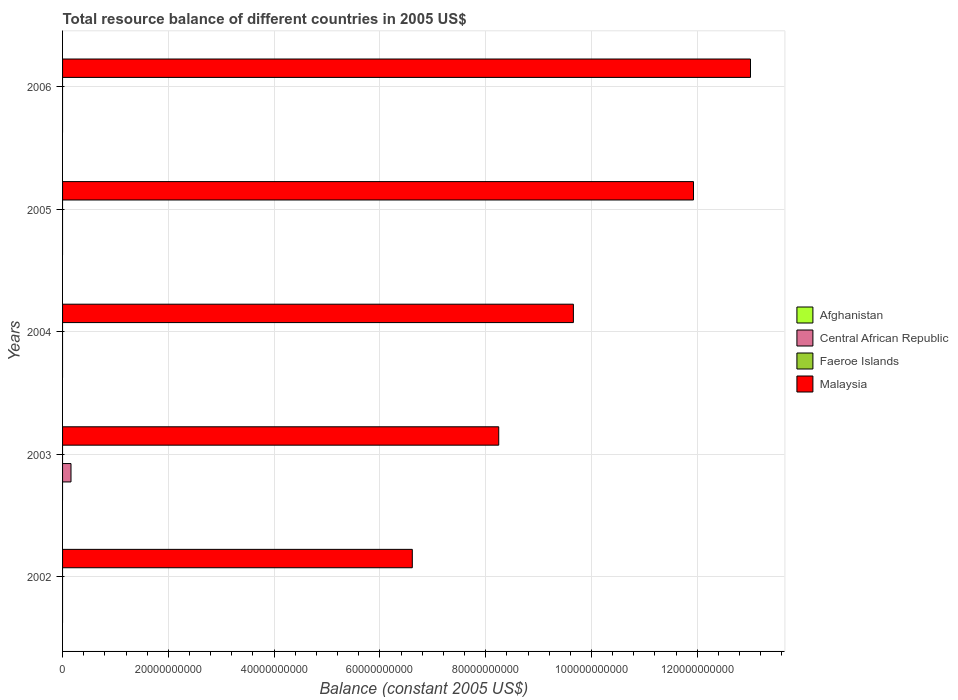Are the number of bars per tick equal to the number of legend labels?
Ensure brevity in your answer.  No. How many bars are there on the 5th tick from the bottom?
Provide a succinct answer. 1. What is the label of the 5th group of bars from the top?
Make the answer very short. 2002. What is the total resource balance in Malaysia in 2005?
Your answer should be compact. 1.19e+11. Across all years, what is the maximum total resource balance in Central African Republic?
Make the answer very short. 1.60e+09. Across all years, what is the minimum total resource balance in Central African Republic?
Give a very brief answer. 0. What is the total total resource balance in Faeroe Islands in the graph?
Offer a terse response. 0. What is the difference between the total resource balance in Malaysia in 2003 and that in 2004?
Your response must be concise. -1.41e+1. What is the difference between the total resource balance in Malaysia in 2006 and the total resource balance in Faeroe Islands in 2005?
Give a very brief answer. 1.30e+11. What is the average total resource balance in Central African Republic per year?
Offer a terse response. 3.19e+08. In how many years, is the total resource balance in Afghanistan greater than 64000000000 US$?
Offer a terse response. 0. What is the difference between the highest and the lowest total resource balance in Malaysia?
Your answer should be very brief. 6.39e+1. In how many years, is the total resource balance in Afghanistan greater than the average total resource balance in Afghanistan taken over all years?
Your answer should be very brief. 0. Is the sum of the total resource balance in Malaysia in 2002 and 2004 greater than the maximum total resource balance in Afghanistan across all years?
Keep it short and to the point. Yes. Is it the case that in every year, the sum of the total resource balance in Central African Republic and total resource balance in Faeroe Islands is greater than the sum of total resource balance in Malaysia and total resource balance in Afghanistan?
Provide a short and direct response. No. Is it the case that in every year, the sum of the total resource balance in Afghanistan and total resource balance in Faeroe Islands is greater than the total resource balance in Central African Republic?
Offer a terse response. No. What is the difference between two consecutive major ticks on the X-axis?
Keep it short and to the point. 2.00e+1. Does the graph contain grids?
Offer a terse response. Yes. Where does the legend appear in the graph?
Ensure brevity in your answer.  Center right. How are the legend labels stacked?
Provide a short and direct response. Vertical. What is the title of the graph?
Offer a terse response. Total resource balance of different countries in 2005 US$. Does "Other small states" appear as one of the legend labels in the graph?
Make the answer very short. No. What is the label or title of the X-axis?
Offer a terse response. Balance (constant 2005 US$). What is the label or title of the Y-axis?
Ensure brevity in your answer.  Years. What is the Balance (constant 2005 US$) of Malaysia in 2002?
Give a very brief answer. 6.61e+1. What is the Balance (constant 2005 US$) of Central African Republic in 2003?
Make the answer very short. 1.60e+09. What is the Balance (constant 2005 US$) of Malaysia in 2003?
Your answer should be compact. 8.25e+1. What is the Balance (constant 2005 US$) of Central African Republic in 2004?
Provide a short and direct response. 0. What is the Balance (constant 2005 US$) in Malaysia in 2004?
Offer a terse response. 9.66e+1. What is the Balance (constant 2005 US$) of Faeroe Islands in 2005?
Ensure brevity in your answer.  0. What is the Balance (constant 2005 US$) of Malaysia in 2005?
Offer a very short reply. 1.19e+11. What is the Balance (constant 2005 US$) in Central African Republic in 2006?
Provide a succinct answer. 0. What is the Balance (constant 2005 US$) in Faeroe Islands in 2006?
Your answer should be compact. 0. What is the Balance (constant 2005 US$) in Malaysia in 2006?
Provide a succinct answer. 1.30e+11. Across all years, what is the maximum Balance (constant 2005 US$) of Central African Republic?
Ensure brevity in your answer.  1.60e+09. Across all years, what is the maximum Balance (constant 2005 US$) of Malaysia?
Make the answer very short. 1.30e+11. Across all years, what is the minimum Balance (constant 2005 US$) of Central African Republic?
Provide a short and direct response. 0. Across all years, what is the minimum Balance (constant 2005 US$) of Malaysia?
Give a very brief answer. 6.61e+1. What is the total Balance (constant 2005 US$) of Central African Republic in the graph?
Your answer should be compact. 1.60e+09. What is the total Balance (constant 2005 US$) in Malaysia in the graph?
Offer a very short reply. 4.94e+11. What is the difference between the Balance (constant 2005 US$) of Malaysia in 2002 and that in 2003?
Offer a very short reply. -1.63e+1. What is the difference between the Balance (constant 2005 US$) of Malaysia in 2002 and that in 2004?
Your answer should be very brief. -3.05e+1. What is the difference between the Balance (constant 2005 US$) in Malaysia in 2002 and that in 2005?
Your answer should be very brief. -5.32e+1. What is the difference between the Balance (constant 2005 US$) of Malaysia in 2002 and that in 2006?
Give a very brief answer. -6.39e+1. What is the difference between the Balance (constant 2005 US$) in Malaysia in 2003 and that in 2004?
Ensure brevity in your answer.  -1.41e+1. What is the difference between the Balance (constant 2005 US$) in Malaysia in 2003 and that in 2005?
Provide a short and direct response. -3.68e+1. What is the difference between the Balance (constant 2005 US$) of Malaysia in 2003 and that in 2006?
Your answer should be very brief. -4.76e+1. What is the difference between the Balance (constant 2005 US$) of Malaysia in 2004 and that in 2005?
Ensure brevity in your answer.  -2.27e+1. What is the difference between the Balance (constant 2005 US$) of Malaysia in 2004 and that in 2006?
Ensure brevity in your answer.  -3.35e+1. What is the difference between the Balance (constant 2005 US$) in Malaysia in 2005 and that in 2006?
Offer a very short reply. -1.08e+1. What is the difference between the Balance (constant 2005 US$) of Central African Republic in 2003 and the Balance (constant 2005 US$) of Malaysia in 2004?
Keep it short and to the point. -9.50e+1. What is the difference between the Balance (constant 2005 US$) of Central African Republic in 2003 and the Balance (constant 2005 US$) of Malaysia in 2005?
Make the answer very short. -1.18e+11. What is the difference between the Balance (constant 2005 US$) of Central African Republic in 2003 and the Balance (constant 2005 US$) of Malaysia in 2006?
Your answer should be very brief. -1.28e+11. What is the average Balance (constant 2005 US$) in Central African Republic per year?
Provide a short and direct response. 3.19e+08. What is the average Balance (constant 2005 US$) of Faeroe Islands per year?
Your response must be concise. 0. What is the average Balance (constant 2005 US$) in Malaysia per year?
Offer a very short reply. 9.89e+1. In the year 2003, what is the difference between the Balance (constant 2005 US$) of Central African Republic and Balance (constant 2005 US$) of Malaysia?
Make the answer very short. -8.09e+1. What is the ratio of the Balance (constant 2005 US$) of Malaysia in 2002 to that in 2003?
Your response must be concise. 0.8. What is the ratio of the Balance (constant 2005 US$) of Malaysia in 2002 to that in 2004?
Your answer should be very brief. 0.68. What is the ratio of the Balance (constant 2005 US$) in Malaysia in 2002 to that in 2005?
Ensure brevity in your answer.  0.55. What is the ratio of the Balance (constant 2005 US$) of Malaysia in 2002 to that in 2006?
Make the answer very short. 0.51. What is the ratio of the Balance (constant 2005 US$) in Malaysia in 2003 to that in 2004?
Offer a very short reply. 0.85. What is the ratio of the Balance (constant 2005 US$) in Malaysia in 2003 to that in 2005?
Provide a short and direct response. 0.69. What is the ratio of the Balance (constant 2005 US$) in Malaysia in 2003 to that in 2006?
Your response must be concise. 0.63. What is the ratio of the Balance (constant 2005 US$) in Malaysia in 2004 to that in 2005?
Make the answer very short. 0.81. What is the ratio of the Balance (constant 2005 US$) in Malaysia in 2004 to that in 2006?
Ensure brevity in your answer.  0.74. What is the ratio of the Balance (constant 2005 US$) of Malaysia in 2005 to that in 2006?
Provide a short and direct response. 0.92. What is the difference between the highest and the second highest Balance (constant 2005 US$) of Malaysia?
Provide a short and direct response. 1.08e+1. What is the difference between the highest and the lowest Balance (constant 2005 US$) of Central African Republic?
Provide a short and direct response. 1.60e+09. What is the difference between the highest and the lowest Balance (constant 2005 US$) of Malaysia?
Keep it short and to the point. 6.39e+1. 